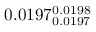Convert formula to latex. <formula><loc_0><loc_0><loc_500><loc_500>0 . 0 1 9 7 _ { 0 . 0 1 9 7 } ^ { 0 . 0 1 9 8 }</formula> 